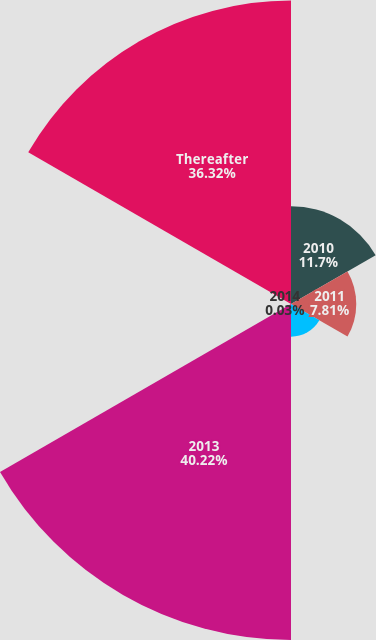<chart> <loc_0><loc_0><loc_500><loc_500><pie_chart><fcel>2010<fcel>2011<fcel>2012<fcel>2013<fcel>2014<fcel>Thereafter<nl><fcel>11.7%<fcel>7.81%<fcel>3.92%<fcel>40.22%<fcel>0.03%<fcel>36.32%<nl></chart> 